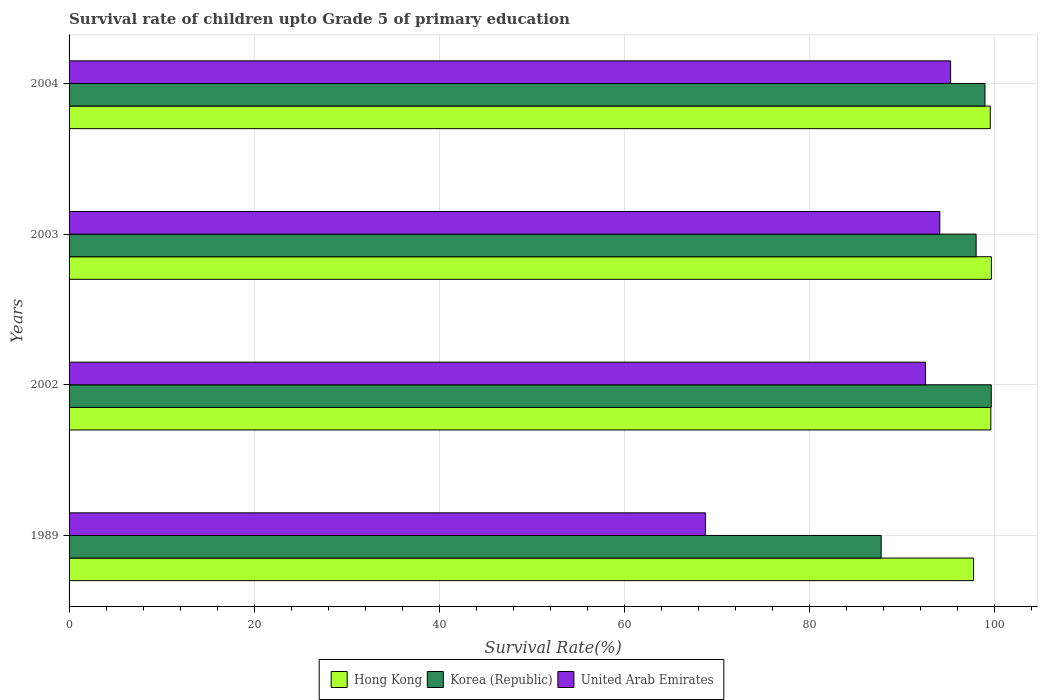How many different coloured bars are there?
Ensure brevity in your answer.  3. Are the number of bars per tick equal to the number of legend labels?
Offer a terse response. Yes. How many bars are there on the 3rd tick from the bottom?
Offer a very short reply. 3. What is the label of the 1st group of bars from the top?
Give a very brief answer. 2004. In how many cases, is the number of bars for a given year not equal to the number of legend labels?
Provide a succinct answer. 0. What is the survival rate of children in United Arab Emirates in 2004?
Keep it short and to the point. 95.22. Across all years, what is the maximum survival rate of children in Hong Kong?
Provide a succinct answer. 99.62. Across all years, what is the minimum survival rate of children in Korea (Republic)?
Provide a short and direct response. 87.72. In which year was the survival rate of children in Korea (Republic) maximum?
Your answer should be very brief. 2002. In which year was the survival rate of children in Korea (Republic) minimum?
Offer a very short reply. 1989. What is the total survival rate of children in Korea (Republic) in the graph?
Offer a very short reply. 384.23. What is the difference between the survival rate of children in Korea (Republic) in 2003 and that in 2004?
Give a very brief answer. -0.96. What is the difference between the survival rate of children in United Arab Emirates in 1989 and the survival rate of children in Korea (Republic) in 2003?
Keep it short and to the point. -29.24. What is the average survival rate of children in Hong Kong per year?
Your response must be concise. 99.1. In the year 1989, what is the difference between the survival rate of children in Hong Kong and survival rate of children in Korea (Republic)?
Provide a succinct answer. 9.98. In how many years, is the survival rate of children in Hong Kong greater than 12 %?
Your response must be concise. 4. What is the ratio of the survival rate of children in Hong Kong in 1989 to that in 2002?
Your response must be concise. 0.98. Is the survival rate of children in Korea (Republic) in 1989 less than that in 2003?
Give a very brief answer. Yes. What is the difference between the highest and the second highest survival rate of children in United Arab Emirates?
Offer a terse response. 1.17. What is the difference between the highest and the lowest survival rate of children in Hong Kong?
Ensure brevity in your answer.  1.93. In how many years, is the survival rate of children in Korea (Republic) greater than the average survival rate of children in Korea (Republic) taken over all years?
Provide a short and direct response. 3. What does the 2nd bar from the top in 1989 represents?
Ensure brevity in your answer.  Korea (Republic). What does the 1st bar from the bottom in 1989 represents?
Give a very brief answer. Hong Kong. Is it the case that in every year, the sum of the survival rate of children in United Arab Emirates and survival rate of children in Korea (Republic) is greater than the survival rate of children in Hong Kong?
Provide a short and direct response. Yes. How many bars are there?
Offer a very short reply. 12. How many years are there in the graph?
Offer a very short reply. 4. What is the difference between two consecutive major ticks on the X-axis?
Offer a very short reply. 20. Are the values on the major ticks of X-axis written in scientific E-notation?
Offer a terse response. No. Where does the legend appear in the graph?
Your response must be concise. Bottom center. How many legend labels are there?
Keep it short and to the point. 3. How are the legend labels stacked?
Your answer should be very brief. Horizontal. What is the title of the graph?
Provide a succinct answer. Survival rate of children upto Grade 5 of primary education. Does "Lower middle income" appear as one of the legend labels in the graph?
Your answer should be compact. No. What is the label or title of the X-axis?
Your response must be concise. Survival Rate(%). What is the label or title of the Y-axis?
Keep it short and to the point. Years. What is the Survival Rate(%) of Hong Kong in 1989?
Provide a succinct answer. 97.7. What is the Survival Rate(%) of Korea (Republic) in 1989?
Offer a very short reply. 87.72. What is the Survival Rate(%) of United Arab Emirates in 1989?
Provide a succinct answer. 68.74. What is the Survival Rate(%) in Hong Kong in 2002?
Offer a terse response. 99.56. What is the Survival Rate(%) of Korea (Republic) in 2002?
Keep it short and to the point. 99.61. What is the Survival Rate(%) in United Arab Emirates in 2002?
Keep it short and to the point. 92.51. What is the Survival Rate(%) in Hong Kong in 2003?
Offer a terse response. 99.62. What is the Survival Rate(%) of Korea (Republic) in 2003?
Your answer should be very brief. 97.98. What is the Survival Rate(%) of United Arab Emirates in 2003?
Make the answer very short. 94.05. What is the Survival Rate(%) in Hong Kong in 2004?
Offer a very short reply. 99.5. What is the Survival Rate(%) in Korea (Republic) in 2004?
Keep it short and to the point. 98.93. What is the Survival Rate(%) of United Arab Emirates in 2004?
Your answer should be very brief. 95.22. Across all years, what is the maximum Survival Rate(%) of Hong Kong?
Ensure brevity in your answer.  99.62. Across all years, what is the maximum Survival Rate(%) of Korea (Republic)?
Provide a short and direct response. 99.61. Across all years, what is the maximum Survival Rate(%) in United Arab Emirates?
Your answer should be compact. 95.22. Across all years, what is the minimum Survival Rate(%) of Hong Kong?
Provide a succinct answer. 97.7. Across all years, what is the minimum Survival Rate(%) of Korea (Republic)?
Keep it short and to the point. 87.72. Across all years, what is the minimum Survival Rate(%) of United Arab Emirates?
Your response must be concise. 68.74. What is the total Survival Rate(%) in Hong Kong in the graph?
Provide a short and direct response. 396.39. What is the total Survival Rate(%) of Korea (Republic) in the graph?
Offer a very short reply. 384.23. What is the total Survival Rate(%) of United Arab Emirates in the graph?
Keep it short and to the point. 350.52. What is the difference between the Survival Rate(%) in Hong Kong in 1989 and that in 2002?
Your answer should be compact. -1.87. What is the difference between the Survival Rate(%) in Korea (Republic) in 1989 and that in 2002?
Offer a terse response. -11.89. What is the difference between the Survival Rate(%) in United Arab Emirates in 1989 and that in 2002?
Provide a succinct answer. -23.77. What is the difference between the Survival Rate(%) in Hong Kong in 1989 and that in 2003?
Your answer should be compact. -1.93. What is the difference between the Survival Rate(%) of Korea (Republic) in 1989 and that in 2003?
Your answer should be compact. -10.26. What is the difference between the Survival Rate(%) in United Arab Emirates in 1989 and that in 2003?
Ensure brevity in your answer.  -25.31. What is the difference between the Survival Rate(%) of Hong Kong in 1989 and that in 2004?
Make the answer very short. -1.81. What is the difference between the Survival Rate(%) of Korea (Republic) in 1989 and that in 2004?
Offer a terse response. -11.21. What is the difference between the Survival Rate(%) in United Arab Emirates in 1989 and that in 2004?
Offer a very short reply. -26.48. What is the difference between the Survival Rate(%) in Hong Kong in 2002 and that in 2003?
Offer a terse response. -0.06. What is the difference between the Survival Rate(%) of Korea (Republic) in 2002 and that in 2003?
Your answer should be very brief. 1.63. What is the difference between the Survival Rate(%) of United Arab Emirates in 2002 and that in 2003?
Your response must be concise. -1.54. What is the difference between the Survival Rate(%) of Hong Kong in 2002 and that in 2004?
Your answer should be very brief. 0.06. What is the difference between the Survival Rate(%) in Korea (Republic) in 2002 and that in 2004?
Ensure brevity in your answer.  0.68. What is the difference between the Survival Rate(%) of United Arab Emirates in 2002 and that in 2004?
Your answer should be very brief. -2.71. What is the difference between the Survival Rate(%) in Hong Kong in 2003 and that in 2004?
Your answer should be compact. 0.12. What is the difference between the Survival Rate(%) of Korea (Republic) in 2003 and that in 2004?
Ensure brevity in your answer.  -0.96. What is the difference between the Survival Rate(%) of United Arab Emirates in 2003 and that in 2004?
Keep it short and to the point. -1.17. What is the difference between the Survival Rate(%) of Hong Kong in 1989 and the Survival Rate(%) of Korea (Republic) in 2002?
Your answer should be very brief. -1.91. What is the difference between the Survival Rate(%) in Hong Kong in 1989 and the Survival Rate(%) in United Arab Emirates in 2002?
Offer a very short reply. 5.19. What is the difference between the Survival Rate(%) of Korea (Republic) in 1989 and the Survival Rate(%) of United Arab Emirates in 2002?
Your answer should be very brief. -4.79. What is the difference between the Survival Rate(%) in Hong Kong in 1989 and the Survival Rate(%) in Korea (Republic) in 2003?
Your response must be concise. -0.28. What is the difference between the Survival Rate(%) of Hong Kong in 1989 and the Survival Rate(%) of United Arab Emirates in 2003?
Make the answer very short. 3.65. What is the difference between the Survival Rate(%) in Korea (Republic) in 1989 and the Survival Rate(%) in United Arab Emirates in 2003?
Your answer should be very brief. -6.33. What is the difference between the Survival Rate(%) of Hong Kong in 1989 and the Survival Rate(%) of Korea (Republic) in 2004?
Offer a terse response. -1.23. What is the difference between the Survival Rate(%) of Hong Kong in 1989 and the Survival Rate(%) of United Arab Emirates in 2004?
Provide a short and direct response. 2.48. What is the difference between the Survival Rate(%) of Korea (Republic) in 1989 and the Survival Rate(%) of United Arab Emirates in 2004?
Ensure brevity in your answer.  -7.5. What is the difference between the Survival Rate(%) in Hong Kong in 2002 and the Survival Rate(%) in Korea (Republic) in 2003?
Give a very brief answer. 1.59. What is the difference between the Survival Rate(%) in Hong Kong in 2002 and the Survival Rate(%) in United Arab Emirates in 2003?
Make the answer very short. 5.51. What is the difference between the Survival Rate(%) in Korea (Republic) in 2002 and the Survival Rate(%) in United Arab Emirates in 2003?
Ensure brevity in your answer.  5.56. What is the difference between the Survival Rate(%) of Hong Kong in 2002 and the Survival Rate(%) of Korea (Republic) in 2004?
Ensure brevity in your answer.  0.63. What is the difference between the Survival Rate(%) in Hong Kong in 2002 and the Survival Rate(%) in United Arab Emirates in 2004?
Offer a very short reply. 4.34. What is the difference between the Survival Rate(%) of Korea (Republic) in 2002 and the Survival Rate(%) of United Arab Emirates in 2004?
Keep it short and to the point. 4.39. What is the difference between the Survival Rate(%) in Hong Kong in 2003 and the Survival Rate(%) in Korea (Republic) in 2004?
Ensure brevity in your answer.  0.69. What is the difference between the Survival Rate(%) of Hong Kong in 2003 and the Survival Rate(%) of United Arab Emirates in 2004?
Keep it short and to the point. 4.4. What is the difference between the Survival Rate(%) in Korea (Republic) in 2003 and the Survival Rate(%) in United Arab Emirates in 2004?
Keep it short and to the point. 2.76. What is the average Survival Rate(%) of Hong Kong per year?
Offer a very short reply. 99.1. What is the average Survival Rate(%) of Korea (Republic) per year?
Give a very brief answer. 96.06. What is the average Survival Rate(%) of United Arab Emirates per year?
Make the answer very short. 87.63. In the year 1989, what is the difference between the Survival Rate(%) of Hong Kong and Survival Rate(%) of Korea (Republic)?
Give a very brief answer. 9.98. In the year 1989, what is the difference between the Survival Rate(%) in Hong Kong and Survival Rate(%) in United Arab Emirates?
Offer a terse response. 28.96. In the year 1989, what is the difference between the Survival Rate(%) of Korea (Republic) and Survival Rate(%) of United Arab Emirates?
Ensure brevity in your answer.  18.98. In the year 2002, what is the difference between the Survival Rate(%) of Hong Kong and Survival Rate(%) of Korea (Republic)?
Offer a terse response. -0.04. In the year 2002, what is the difference between the Survival Rate(%) of Hong Kong and Survival Rate(%) of United Arab Emirates?
Your response must be concise. 7.06. In the year 2002, what is the difference between the Survival Rate(%) of Korea (Republic) and Survival Rate(%) of United Arab Emirates?
Your answer should be very brief. 7.1. In the year 2003, what is the difference between the Survival Rate(%) of Hong Kong and Survival Rate(%) of Korea (Republic)?
Provide a succinct answer. 1.65. In the year 2003, what is the difference between the Survival Rate(%) of Hong Kong and Survival Rate(%) of United Arab Emirates?
Your answer should be very brief. 5.57. In the year 2003, what is the difference between the Survival Rate(%) of Korea (Republic) and Survival Rate(%) of United Arab Emirates?
Keep it short and to the point. 3.92. In the year 2004, what is the difference between the Survival Rate(%) of Hong Kong and Survival Rate(%) of Korea (Republic)?
Give a very brief answer. 0.57. In the year 2004, what is the difference between the Survival Rate(%) of Hong Kong and Survival Rate(%) of United Arab Emirates?
Ensure brevity in your answer.  4.28. In the year 2004, what is the difference between the Survival Rate(%) of Korea (Republic) and Survival Rate(%) of United Arab Emirates?
Make the answer very short. 3.71. What is the ratio of the Survival Rate(%) in Hong Kong in 1989 to that in 2002?
Make the answer very short. 0.98. What is the ratio of the Survival Rate(%) in Korea (Republic) in 1989 to that in 2002?
Your response must be concise. 0.88. What is the ratio of the Survival Rate(%) of United Arab Emirates in 1989 to that in 2002?
Offer a terse response. 0.74. What is the ratio of the Survival Rate(%) of Hong Kong in 1989 to that in 2003?
Make the answer very short. 0.98. What is the ratio of the Survival Rate(%) of Korea (Republic) in 1989 to that in 2003?
Provide a short and direct response. 0.9. What is the ratio of the Survival Rate(%) in United Arab Emirates in 1989 to that in 2003?
Make the answer very short. 0.73. What is the ratio of the Survival Rate(%) of Hong Kong in 1989 to that in 2004?
Provide a succinct answer. 0.98. What is the ratio of the Survival Rate(%) in Korea (Republic) in 1989 to that in 2004?
Provide a short and direct response. 0.89. What is the ratio of the Survival Rate(%) in United Arab Emirates in 1989 to that in 2004?
Provide a succinct answer. 0.72. What is the ratio of the Survival Rate(%) of Hong Kong in 2002 to that in 2003?
Provide a succinct answer. 1. What is the ratio of the Survival Rate(%) of Korea (Republic) in 2002 to that in 2003?
Your response must be concise. 1.02. What is the ratio of the Survival Rate(%) in United Arab Emirates in 2002 to that in 2003?
Offer a terse response. 0.98. What is the ratio of the Survival Rate(%) in Hong Kong in 2002 to that in 2004?
Offer a terse response. 1. What is the ratio of the Survival Rate(%) in Korea (Republic) in 2002 to that in 2004?
Make the answer very short. 1.01. What is the ratio of the Survival Rate(%) of United Arab Emirates in 2002 to that in 2004?
Provide a succinct answer. 0.97. What is the ratio of the Survival Rate(%) of Hong Kong in 2003 to that in 2004?
Ensure brevity in your answer.  1. What is the ratio of the Survival Rate(%) of Korea (Republic) in 2003 to that in 2004?
Provide a short and direct response. 0.99. What is the difference between the highest and the second highest Survival Rate(%) in Hong Kong?
Keep it short and to the point. 0.06. What is the difference between the highest and the second highest Survival Rate(%) of Korea (Republic)?
Your response must be concise. 0.68. What is the difference between the highest and the second highest Survival Rate(%) of United Arab Emirates?
Your answer should be very brief. 1.17. What is the difference between the highest and the lowest Survival Rate(%) of Hong Kong?
Offer a very short reply. 1.93. What is the difference between the highest and the lowest Survival Rate(%) in Korea (Republic)?
Your response must be concise. 11.89. What is the difference between the highest and the lowest Survival Rate(%) in United Arab Emirates?
Provide a succinct answer. 26.48. 